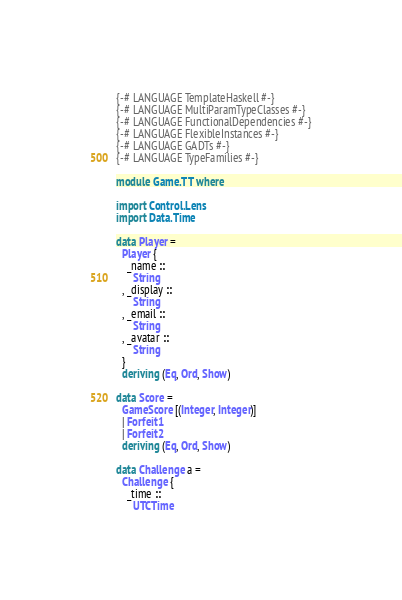Convert code to text. <code><loc_0><loc_0><loc_500><loc_500><_Haskell_>{-# LANGUAGE TemplateHaskell #-}
{-# LANGUAGE MultiParamTypeClasses #-}
{-# LANGUAGE FunctionalDependencies #-}
{-# LANGUAGE FlexibleInstances #-}
{-# LANGUAGE GADTs #-}
{-# LANGUAGE TypeFamilies #-}

module Game.TT where

import Control.Lens
import Data.Time

data Player =
  Player {
    _name :: 
      String
  , _display ::
      String
  , _email ::
      String
  , _avatar ::
      String
  }
  deriving (Eq, Ord, Show)

data Score =
  GameScore [(Integer, Integer)]
  | Forfeit1
  | Forfeit2
  deriving (Eq, Ord, Show)
  
data Challenge a =
  Challenge {
    _time ::
      UTCTime</code> 